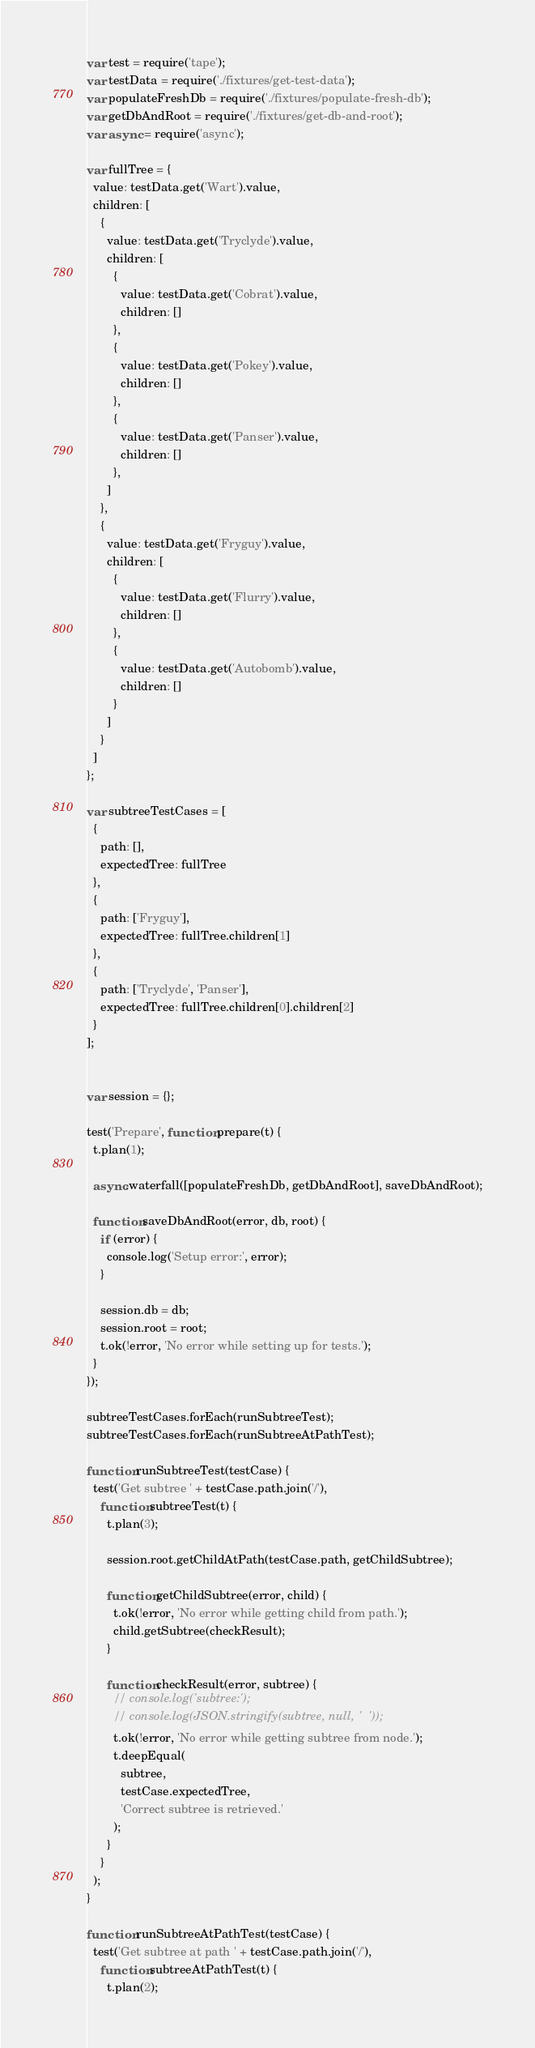Convert code to text. <code><loc_0><loc_0><loc_500><loc_500><_JavaScript_>var test = require('tape');
var testData = require('./fixtures/get-test-data');
var populateFreshDb = require('./fixtures/populate-fresh-db');
var getDbAndRoot = require('./fixtures/get-db-and-root');
var async = require('async');

var fullTree = {
  value: testData.get('Wart').value,
  children: [
    {
      value: testData.get('Tryclyde').value,
      children: [
        {
          value: testData.get('Cobrat').value,
          children: []
        },
        {
          value: testData.get('Pokey').value,
          children: []
        },
        {
          value: testData.get('Panser').value,
          children: []
        },
      ]
    },
    {
      value: testData.get('Fryguy').value,
      children: [
        {
          value: testData.get('Flurry').value,
          children: []
        },
        {
          value: testData.get('Autobomb').value,
          children: []
        }
      ]
    }
  ]
};

var subtreeTestCases = [
  {
    path: [],
    expectedTree: fullTree
  },
  {
    path: ['Fryguy'],
    expectedTree: fullTree.children[1]
  },
  {
    path: ['Tryclyde', 'Panser'],
    expectedTree: fullTree.children[0].children[2]
  }
];


var session = {};

test('Prepare', function prepare(t) {
  t.plan(1);

  async.waterfall([populateFreshDb, getDbAndRoot], saveDbAndRoot);

  function saveDbAndRoot(error, db, root) {
    if (error) {
      console.log('Setup error:', error);
    }

    session.db = db;
    session.root = root;
    t.ok(!error, 'No error while setting up for tests.');
  }
});

subtreeTestCases.forEach(runSubtreeTest);
subtreeTestCases.forEach(runSubtreeAtPathTest);

function runSubtreeTest(testCase) {
  test('Get subtree ' + testCase.path.join('/'),
    function subtreeTest(t) {
      t.plan(3);

      session.root.getChildAtPath(testCase.path, getChildSubtree);

      function getChildSubtree(error, child) {
        t.ok(!error, 'No error while getting child from path.');
        child.getSubtree(checkResult);
      }

      function checkResult(error, subtree) {
        // console.log('subtree:');
        // console.log(JSON.stringify(subtree, null, '  '));
        t.ok(!error, 'No error while getting subtree from node.');
        t.deepEqual(
          subtree,
          testCase.expectedTree,
          'Correct subtree is retrieved.'
        );
      }
    }
  );
}

function runSubtreeAtPathTest(testCase) {
  test('Get subtree at path ' + testCase.path.join('/'),
    function subtreeAtPathTest(t) {
      t.plan(2);
</code> 